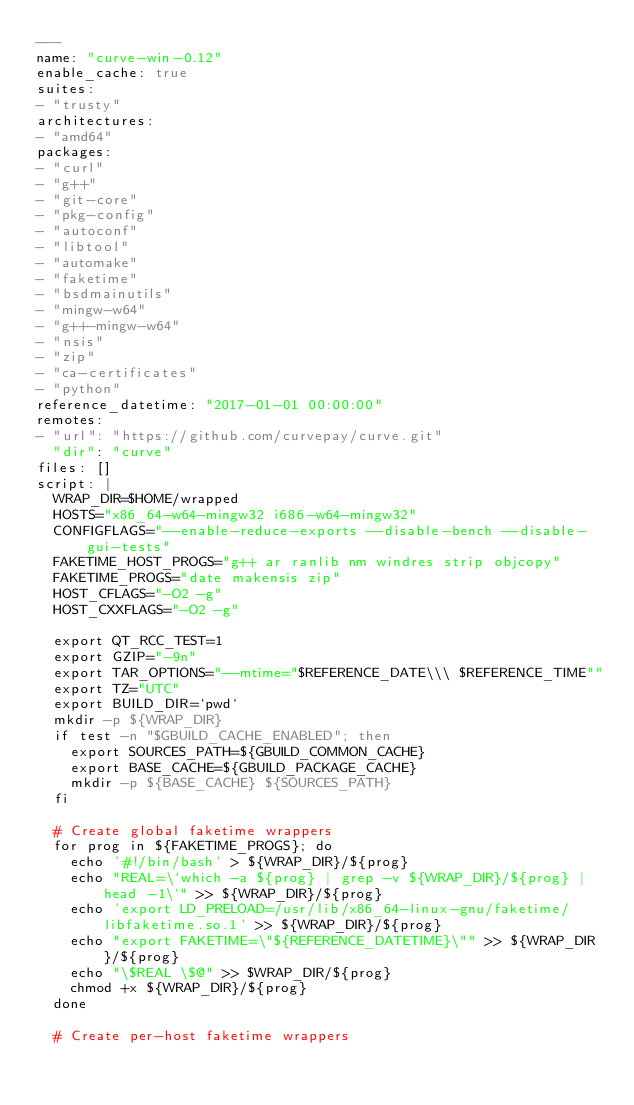Convert code to text. <code><loc_0><loc_0><loc_500><loc_500><_YAML_>---
name: "curve-win-0.12"
enable_cache: true
suites:
- "trusty"
architectures:
- "amd64"
packages: 
- "curl"
- "g++"
- "git-core"
- "pkg-config"
- "autoconf"
- "libtool"
- "automake"
- "faketime"
- "bsdmainutils"
- "mingw-w64"
- "g++-mingw-w64"
- "nsis"
- "zip"
- "ca-certificates"
- "python"
reference_datetime: "2017-01-01 00:00:00"
remotes:
- "url": "https://github.com/curvepay/curve.git"
  "dir": "curve"
files: []
script: |
  WRAP_DIR=$HOME/wrapped
  HOSTS="x86_64-w64-mingw32 i686-w64-mingw32"
  CONFIGFLAGS="--enable-reduce-exports --disable-bench --disable-gui-tests"
  FAKETIME_HOST_PROGS="g++ ar ranlib nm windres strip objcopy"
  FAKETIME_PROGS="date makensis zip"
  HOST_CFLAGS="-O2 -g"
  HOST_CXXFLAGS="-O2 -g"

  export QT_RCC_TEST=1
  export GZIP="-9n"
  export TAR_OPTIONS="--mtime="$REFERENCE_DATE\\\ $REFERENCE_TIME""
  export TZ="UTC"
  export BUILD_DIR=`pwd`
  mkdir -p ${WRAP_DIR}
  if test -n "$GBUILD_CACHE_ENABLED"; then
    export SOURCES_PATH=${GBUILD_COMMON_CACHE}
    export BASE_CACHE=${GBUILD_PACKAGE_CACHE}
    mkdir -p ${BASE_CACHE} ${SOURCES_PATH}
  fi

  # Create global faketime wrappers
  for prog in ${FAKETIME_PROGS}; do
    echo '#!/bin/bash' > ${WRAP_DIR}/${prog}
    echo "REAL=\`which -a ${prog} | grep -v ${WRAP_DIR}/${prog} | head -1\`" >> ${WRAP_DIR}/${prog}
    echo 'export LD_PRELOAD=/usr/lib/x86_64-linux-gnu/faketime/libfaketime.so.1' >> ${WRAP_DIR}/${prog}
    echo "export FAKETIME=\"${REFERENCE_DATETIME}\"" >> ${WRAP_DIR}/${prog}
    echo "\$REAL \$@" >> $WRAP_DIR/${prog}
    chmod +x ${WRAP_DIR}/${prog}
  done

  # Create per-host faketime wrappers</code> 